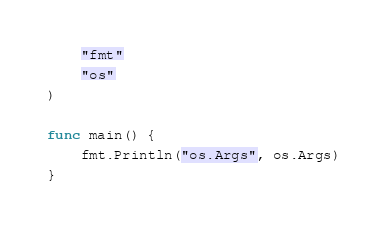<code> <loc_0><loc_0><loc_500><loc_500><_Go_>	"fmt"
	"os"
)

func main() {
	fmt.Println("os.Args", os.Args)
}
</code> 